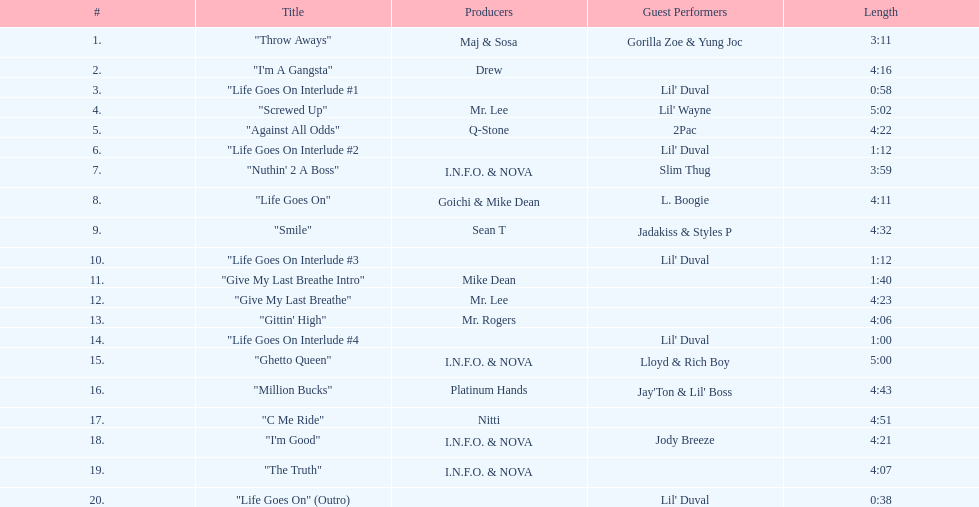What is the opening song including lil' duval? "Life Goes On Interlude #1. 